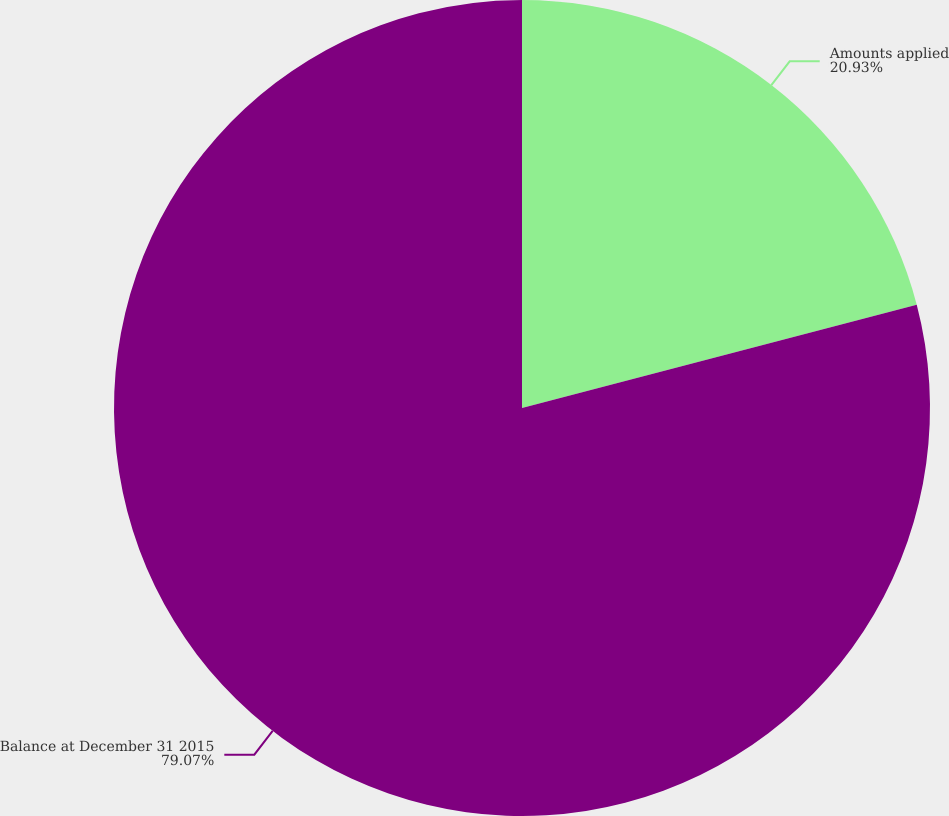<chart> <loc_0><loc_0><loc_500><loc_500><pie_chart><fcel>Amounts applied<fcel>Balance at December 31 2015<nl><fcel>20.93%<fcel>79.07%<nl></chart> 